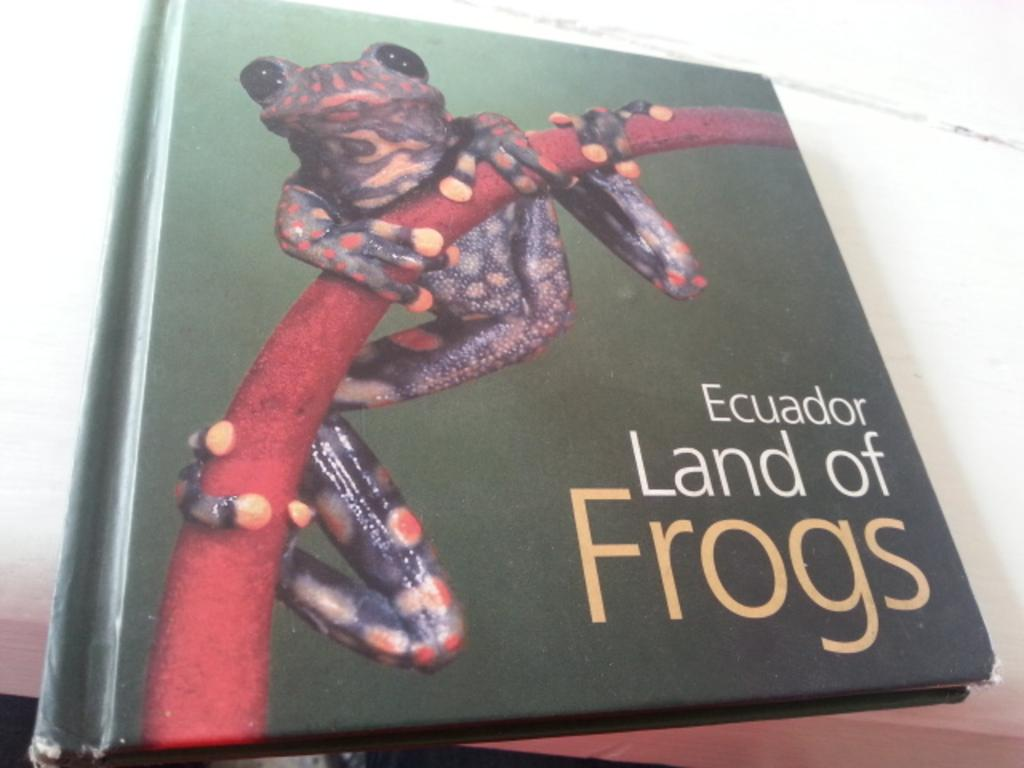What object is present in the image that is typically used for reading? There is a book in the image. What is on top of the book in the image? There is a frog on the book. What can be found on the pages of the book? There is text on the book. What type of trick does the frog perform on the book in the image? There is no trick being performed by the frog on the book in the image; it is simply sitting on the book. Can you see any bats in the image? There are no bats present in the image. 